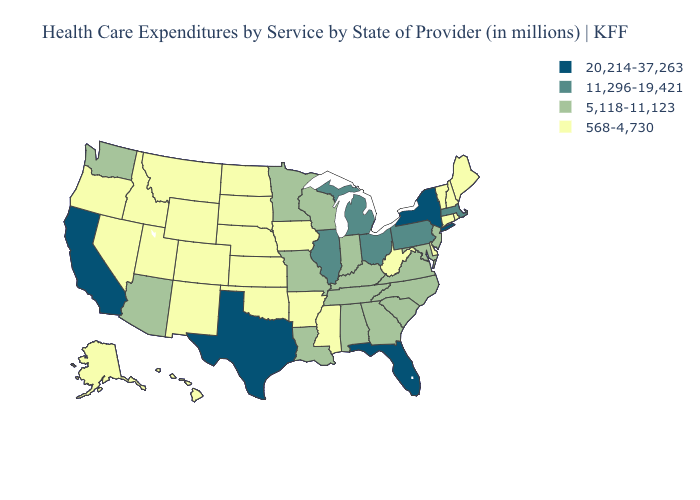What is the value of Florida?
Concise answer only. 20,214-37,263. Name the states that have a value in the range 20,214-37,263?
Answer briefly. California, Florida, New York, Texas. Name the states that have a value in the range 11,296-19,421?
Concise answer only. Illinois, Massachusetts, Michigan, Ohio, Pennsylvania. What is the value of Washington?
Answer briefly. 5,118-11,123. Name the states that have a value in the range 568-4,730?
Be succinct. Alaska, Arkansas, Colorado, Connecticut, Delaware, Hawaii, Idaho, Iowa, Kansas, Maine, Mississippi, Montana, Nebraska, Nevada, New Hampshire, New Mexico, North Dakota, Oklahoma, Oregon, Rhode Island, South Dakota, Utah, Vermont, West Virginia, Wyoming. Does Virginia have the same value as Colorado?
Be succinct. No. What is the value of South Dakota?
Short answer required. 568-4,730. How many symbols are there in the legend?
Quick response, please. 4. Which states hav the highest value in the South?
Quick response, please. Florida, Texas. Name the states that have a value in the range 20,214-37,263?
Quick response, please. California, Florida, New York, Texas. Name the states that have a value in the range 11,296-19,421?
Short answer required. Illinois, Massachusetts, Michigan, Ohio, Pennsylvania. Among the states that border Michigan , does Wisconsin have the highest value?
Write a very short answer. No. Which states have the highest value in the USA?
Short answer required. California, Florida, New York, Texas. Does the first symbol in the legend represent the smallest category?
Answer briefly. No. What is the value of Vermont?
Answer briefly. 568-4,730. 